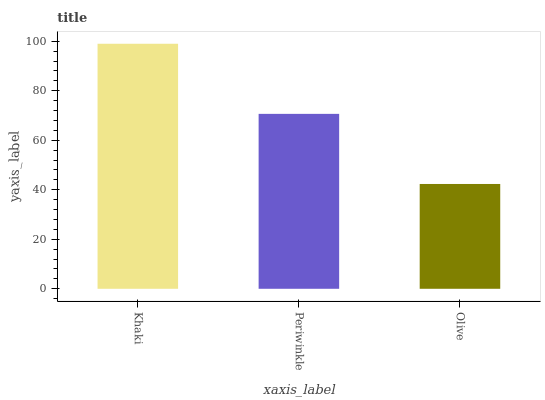Is Olive the minimum?
Answer yes or no. Yes. Is Khaki the maximum?
Answer yes or no. Yes. Is Periwinkle the minimum?
Answer yes or no. No. Is Periwinkle the maximum?
Answer yes or no. No. Is Khaki greater than Periwinkle?
Answer yes or no. Yes. Is Periwinkle less than Khaki?
Answer yes or no. Yes. Is Periwinkle greater than Khaki?
Answer yes or no. No. Is Khaki less than Periwinkle?
Answer yes or no. No. Is Periwinkle the high median?
Answer yes or no. Yes. Is Periwinkle the low median?
Answer yes or no. Yes. Is Khaki the high median?
Answer yes or no. No. Is Olive the low median?
Answer yes or no. No. 